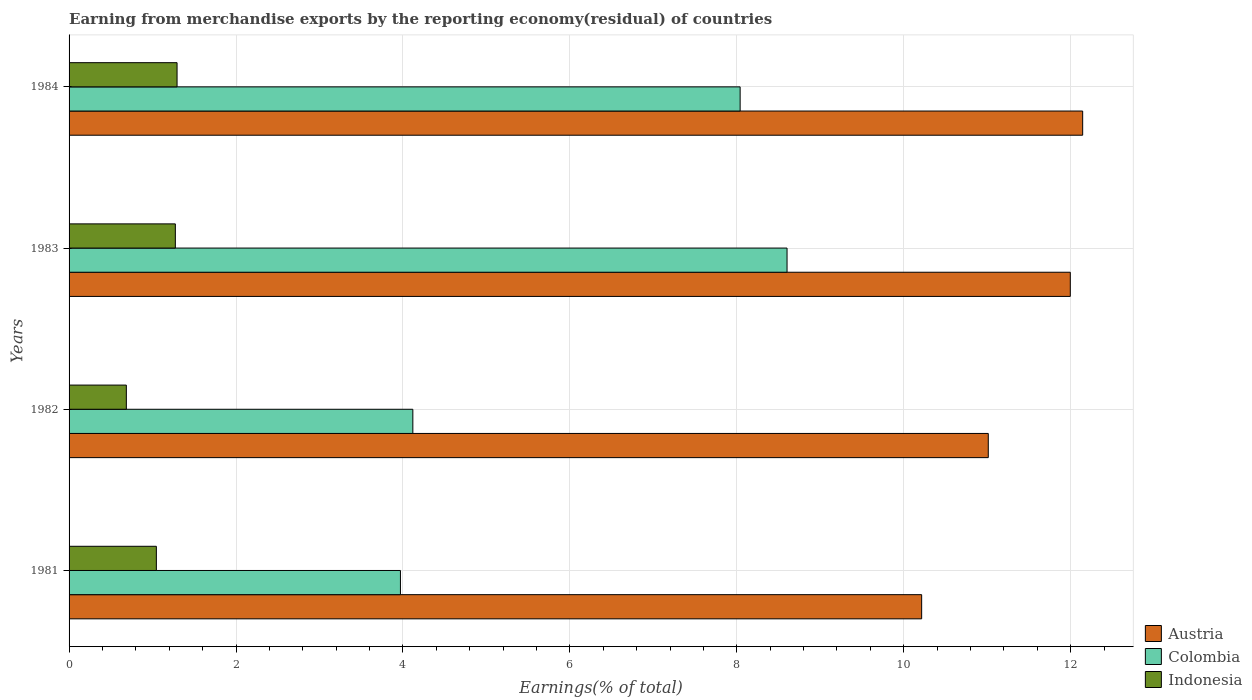How many different coloured bars are there?
Your response must be concise. 3. How many bars are there on the 2nd tick from the top?
Ensure brevity in your answer.  3. How many bars are there on the 1st tick from the bottom?
Give a very brief answer. 3. What is the percentage of amount earned from merchandise exports in Indonesia in 1982?
Offer a terse response. 0.69. Across all years, what is the maximum percentage of amount earned from merchandise exports in Indonesia?
Provide a succinct answer. 1.29. Across all years, what is the minimum percentage of amount earned from merchandise exports in Colombia?
Offer a very short reply. 3.97. In which year was the percentage of amount earned from merchandise exports in Austria maximum?
Offer a terse response. 1984. What is the total percentage of amount earned from merchandise exports in Indonesia in the graph?
Your answer should be very brief. 4.3. What is the difference between the percentage of amount earned from merchandise exports in Colombia in 1981 and that in 1982?
Offer a terse response. -0.15. What is the difference between the percentage of amount earned from merchandise exports in Austria in 1981 and the percentage of amount earned from merchandise exports in Indonesia in 1982?
Your answer should be very brief. 9.53. What is the average percentage of amount earned from merchandise exports in Austria per year?
Offer a very short reply. 11.34. In the year 1984, what is the difference between the percentage of amount earned from merchandise exports in Indonesia and percentage of amount earned from merchandise exports in Colombia?
Provide a succinct answer. -6.75. What is the ratio of the percentage of amount earned from merchandise exports in Colombia in 1981 to that in 1982?
Offer a terse response. 0.96. Is the percentage of amount earned from merchandise exports in Austria in 1981 less than that in 1984?
Your response must be concise. Yes. What is the difference between the highest and the second highest percentage of amount earned from merchandise exports in Austria?
Provide a short and direct response. 0.15. What is the difference between the highest and the lowest percentage of amount earned from merchandise exports in Indonesia?
Offer a terse response. 0.61. In how many years, is the percentage of amount earned from merchandise exports in Indonesia greater than the average percentage of amount earned from merchandise exports in Indonesia taken over all years?
Provide a short and direct response. 2. What does the 2nd bar from the top in 1984 represents?
Keep it short and to the point. Colombia. Is it the case that in every year, the sum of the percentage of amount earned from merchandise exports in Indonesia and percentage of amount earned from merchandise exports in Austria is greater than the percentage of amount earned from merchandise exports in Colombia?
Offer a terse response. Yes. How many bars are there?
Your response must be concise. 12. Are all the bars in the graph horizontal?
Provide a short and direct response. Yes. Does the graph contain any zero values?
Your response must be concise. No. Does the graph contain grids?
Offer a terse response. Yes. How many legend labels are there?
Make the answer very short. 3. What is the title of the graph?
Give a very brief answer. Earning from merchandise exports by the reporting economy(residual) of countries. Does "Oman" appear as one of the legend labels in the graph?
Your answer should be compact. No. What is the label or title of the X-axis?
Offer a terse response. Earnings(% of total). What is the label or title of the Y-axis?
Provide a succinct answer. Years. What is the Earnings(% of total) in Austria in 1981?
Ensure brevity in your answer.  10.22. What is the Earnings(% of total) in Colombia in 1981?
Offer a very short reply. 3.97. What is the Earnings(% of total) of Indonesia in 1981?
Keep it short and to the point. 1.05. What is the Earnings(% of total) of Austria in 1982?
Make the answer very short. 11.01. What is the Earnings(% of total) of Colombia in 1982?
Your answer should be compact. 4.12. What is the Earnings(% of total) of Indonesia in 1982?
Your response must be concise. 0.69. What is the Earnings(% of total) of Austria in 1983?
Your response must be concise. 12. What is the Earnings(% of total) of Colombia in 1983?
Offer a terse response. 8.6. What is the Earnings(% of total) in Indonesia in 1983?
Give a very brief answer. 1.27. What is the Earnings(% of total) in Austria in 1984?
Offer a very short reply. 12.14. What is the Earnings(% of total) in Colombia in 1984?
Provide a short and direct response. 8.04. What is the Earnings(% of total) in Indonesia in 1984?
Your answer should be very brief. 1.29. Across all years, what is the maximum Earnings(% of total) in Austria?
Offer a terse response. 12.14. Across all years, what is the maximum Earnings(% of total) of Colombia?
Your answer should be compact. 8.6. Across all years, what is the maximum Earnings(% of total) in Indonesia?
Your answer should be very brief. 1.29. Across all years, what is the minimum Earnings(% of total) of Austria?
Offer a very short reply. 10.22. Across all years, what is the minimum Earnings(% of total) in Colombia?
Provide a short and direct response. 3.97. Across all years, what is the minimum Earnings(% of total) of Indonesia?
Offer a very short reply. 0.69. What is the total Earnings(% of total) of Austria in the graph?
Your response must be concise. 45.37. What is the total Earnings(% of total) of Colombia in the graph?
Offer a terse response. 24.73. What is the total Earnings(% of total) of Indonesia in the graph?
Your answer should be very brief. 4.3. What is the difference between the Earnings(% of total) of Austria in 1981 and that in 1982?
Your response must be concise. -0.8. What is the difference between the Earnings(% of total) in Colombia in 1981 and that in 1982?
Keep it short and to the point. -0.15. What is the difference between the Earnings(% of total) of Indonesia in 1981 and that in 1982?
Your answer should be compact. 0.36. What is the difference between the Earnings(% of total) in Austria in 1981 and that in 1983?
Make the answer very short. -1.78. What is the difference between the Earnings(% of total) in Colombia in 1981 and that in 1983?
Ensure brevity in your answer.  -4.63. What is the difference between the Earnings(% of total) in Indonesia in 1981 and that in 1983?
Provide a succinct answer. -0.23. What is the difference between the Earnings(% of total) of Austria in 1981 and that in 1984?
Offer a terse response. -1.93. What is the difference between the Earnings(% of total) in Colombia in 1981 and that in 1984?
Provide a succinct answer. -4.07. What is the difference between the Earnings(% of total) in Indonesia in 1981 and that in 1984?
Provide a succinct answer. -0.25. What is the difference between the Earnings(% of total) of Austria in 1982 and that in 1983?
Ensure brevity in your answer.  -0.98. What is the difference between the Earnings(% of total) of Colombia in 1982 and that in 1983?
Provide a short and direct response. -4.48. What is the difference between the Earnings(% of total) of Indonesia in 1982 and that in 1983?
Offer a terse response. -0.59. What is the difference between the Earnings(% of total) of Austria in 1982 and that in 1984?
Your response must be concise. -1.13. What is the difference between the Earnings(% of total) of Colombia in 1982 and that in 1984?
Ensure brevity in your answer.  -3.92. What is the difference between the Earnings(% of total) in Indonesia in 1982 and that in 1984?
Your answer should be very brief. -0.61. What is the difference between the Earnings(% of total) in Austria in 1983 and that in 1984?
Keep it short and to the point. -0.15. What is the difference between the Earnings(% of total) of Colombia in 1983 and that in 1984?
Make the answer very short. 0.56. What is the difference between the Earnings(% of total) in Indonesia in 1983 and that in 1984?
Your answer should be compact. -0.02. What is the difference between the Earnings(% of total) of Austria in 1981 and the Earnings(% of total) of Colombia in 1982?
Offer a very short reply. 6.1. What is the difference between the Earnings(% of total) in Austria in 1981 and the Earnings(% of total) in Indonesia in 1982?
Give a very brief answer. 9.53. What is the difference between the Earnings(% of total) in Colombia in 1981 and the Earnings(% of total) in Indonesia in 1982?
Give a very brief answer. 3.28. What is the difference between the Earnings(% of total) of Austria in 1981 and the Earnings(% of total) of Colombia in 1983?
Provide a short and direct response. 1.61. What is the difference between the Earnings(% of total) in Austria in 1981 and the Earnings(% of total) in Indonesia in 1983?
Offer a terse response. 8.94. What is the difference between the Earnings(% of total) of Colombia in 1981 and the Earnings(% of total) of Indonesia in 1983?
Make the answer very short. 2.7. What is the difference between the Earnings(% of total) in Austria in 1981 and the Earnings(% of total) in Colombia in 1984?
Offer a terse response. 2.17. What is the difference between the Earnings(% of total) of Austria in 1981 and the Earnings(% of total) of Indonesia in 1984?
Offer a terse response. 8.92. What is the difference between the Earnings(% of total) in Colombia in 1981 and the Earnings(% of total) in Indonesia in 1984?
Ensure brevity in your answer.  2.68. What is the difference between the Earnings(% of total) of Austria in 1982 and the Earnings(% of total) of Colombia in 1983?
Give a very brief answer. 2.41. What is the difference between the Earnings(% of total) of Austria in 1982 and the Earnings(% of total) of Indonesia in 1983?
Your answer should be compact. 9.74. What is the difference between the Earnings(% of total) in Colombia in 1982 and the Earnings(% of total) in Indonesia in 1983?
Offer a very short reply. 2.85. What is the difference between the Earnings(% of total) in Austria in 1982 and the Earnings(% of total) in Colombia in 1984?
Your response must be concise. 2.97. What is the difference between the Earnings(% of total) of Austria in 1982 and the Earnings(% of total) of Indonesia in 1984?
Give a very brief answer. 9.72. What is the difference between the Earnings(% of total) in Colombia in 1982 and the Earnings(% of total) in Indonesia in 1984?
Offer a terse response. 2.83. What is the difference between the Earnings(% of total) in Austria in 1983 and the Earnings(% of total) in Colombia in 1984?
Your answer should be very brief. 3.96. What is the difference between the Earnings(% of total) of Austria in 1983 and the Earnings(% of total) of Indonesia in 1984?
Provide a succinct answer. 10.7. What is the difference between the Earnings(% of total) in Colombia in 1983 and the Earnings(% of total) in Indonesia in 1984?
Give a very brief answer. 7.31. What is the average Earnings(% of total) in Austria per year?
Your answer should be compact. 11.34. What is the average Earnings(% of total) of Colombia per year?
Provide a succinct answer. 6.18. What is the average Earnings(% of total) in Indonesia per year?
Give a very brief answer. 1.07. In the year 1981, what is the difference between the Earnings(% of total) of Austria and Earnings(% of total) of Colombia?
Offer a terse response. 6.24. In the year 1981, what is the difference between the Earnings(% of total) in Austria and Earnings(% of total) in Indonesia?
Provide a short and direct response. 9.17. In the year 1981, what is the difference between the Earnings(% of total) of Colombia and Earnings(% of total) of Indonesia?
Ensure brevity in your answer.  2.92. In the year 1982, what is the difference between the Earnings(% of total) in Austria and Earnings(% of total) in Colombia?
Offer a terse response. 6.89. In the year 1982, what is the difference between the Earnings(% of total) in Austria and Earnings(% of total) in Indonesia?
Your answer should be compact. 10.33. In the year 1982, what is the difference between the Earnings(% of total) in Colombia and Earnings(% of total) in Indonesia?
Your answer should be compact. 3.43. In the year 1983, what is the difference between the Earnings(% of total) of Austria and Earnings(% of total) of Colombia?
Your answer should be compact. 3.39. In the year 1983, what is the difference between the Earnings(% of total) of Austria and Earnings(% of total) of Indonesia?
Provide a succinct answer. 10.72. In the year 1983, what is the difference between the Earnings(% of total) in Colombia and Earnings(% of total) in Indonesia?
Offer a very short reply. 7.33. In the year 1984, what is the difference between the Earnings(% of total) of Austria and Earnings(% of total) of Colombia?
Provide a short and direct response. 4.1. In the year 1984, what is the difference between the Earnings(% of total) in Austria and Earnings(% of total) in Indonesia?
Your response must be concise. 10.85. In the year 1984, what is the difference between the Earnings(% of total) of Colombia and Earnings(% of total) of Indonesia?
Ensure brevity in your answer.  6.75. What is the ratio of the Earnings(% of total) in Austria in 1981 to that in 1982?
Offer a very short reply. 0.93. What is the ratio of the Earnings(% of total) in Colombia in 1981 to that in 1982?
Ensure brevity in your answer.  0.96. What is the ratio of the Earnings(% of total) of Indonesia in 1981 to that in 1982?
Ensure brevity in your answer.  1.52. What is the ratio of the Earnings(% of total) of Austria in 1981 to that in 1983?
Provide a succinct answer. 0.85. What is the ratio of the Earnings(% of total) in Colombia in 1981 to that in 1983?
Your answer should be very brief. 0.46. What is the ratio of the Earnings(% of total) in Indonesia in 1981 to that in 1983?
Keep it short and to the point. 0.82. What is the ratio of the Earnings(% of total) of Austria in 1981 to that in 1984?
Offer a terse response. 0.84. What is the ratio of the Earnings(% of total) in Colombia in 1981 to that in 1984?
Keep it short and to the point. 0.49. What is the ratio of the Earnings(% of total) in Indonesia in 1981 to that in 1984?
Keep it short and to the point. 0.81. What is the ratio of the Earnings(% of total) in Austria in 1982 to that in 1983?
Your response must be concise. 0.92. What is the ratio of the Earnings(% of total) in Colombia in 1982 to that in 1983?
Offer a very short reply. 0.48. What is the ratio of the Earnings(% of total) in Indonesia in 1982 to that in 1983?
Make the answer very short. 0.54. What is the ratio of the Earnings(% of total) in Austria in 1982 to that in 1984?
Your answer should be very brief. 0.91. What is the ratio of the Earnings(% of total) of Colombia in 1982 to that in 1984?
Provide a short and direct response. 0.51. What is the ratio of the Earnings(% of total) of Indonesia in 1982 to that in 1984?
Give a very brief answer. 0.53. What is the ratio of the Earnings(% of total) of Austria in 1983 to that in 1984?
Offer a terse response. 0.99. What is the ratio of the Earnings(% of total) of Colombia in 1983 to that in 1984?
Provide a short and direct response. 1.07. What is the ratio of the Earnings(% of total) in Indonesia in 1983 to that in 1984?
Your answer should be compact. 0.98. What is the difference between the highest and the second highest Earnings(% of total) in Austria?
Your response must be concise. 0.15. What is the difference between the highest and the second highest Earnings(% of total) of Colombia?
Give a very brief answer. 0.56. What is the difference between the highest and the second highest Earnings(% of total) in Indonesia?
Offer a terse response. 0.02. What is the difference between the highest and the lowest Earnings(% of total) of Austria?
Your answer should be very brief. 1.93. What is the difference between the highest and the lowest Earnings(% of total) of Colombia?
Offer a terse response. 4.63. What is the difference between the highest and the lowest Earnings(% of total) in Indonesia?
Provide a short and direct response. 0.61. 